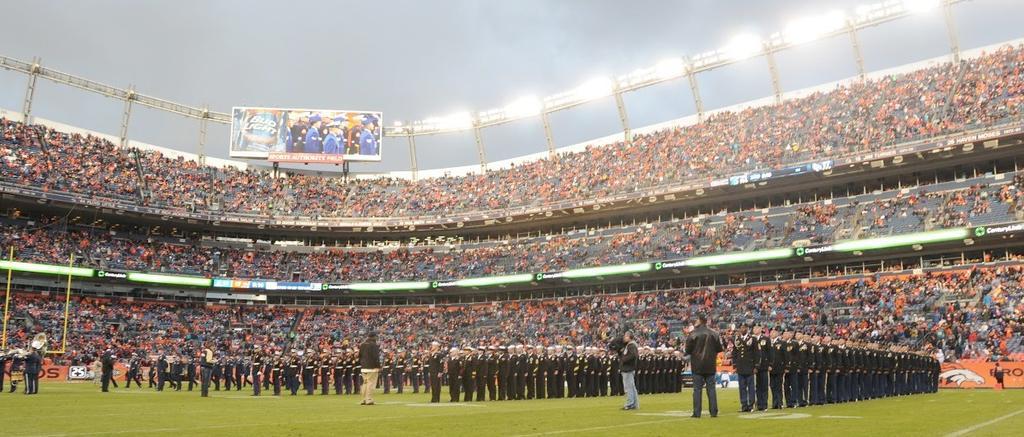In one or two sentences, can you explain what this image depicts? In the picture we can see the stadium with a grass surface on it, we can see many people are standing with uniforms in the row wise and one man is standing with the camera and in the background, we can see many audiences sitting and top of them we can see lights and hoarding and behind it we can see the sky. 